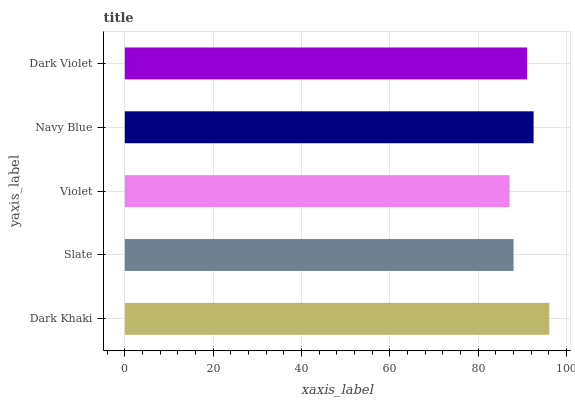Is Violet the minimum?
Answer yes or no. Yes. Is Dark Khaki the maximum?
Answer yes or no. Yes. Is Slate the minimum?
Answer yes or no. No. Is Slate the maximum?
Answer yes or no. No. Is Dark Khaki greater than Slate?
Answer yes or no. Yes. Is Slate less than Dark Khaki?
Answer yes or no. Yes. Is Slate greater than Dark Khaki?
Answer yes or no. No. Is Dark Khaki less than Slate?
Answer yes or no. No. Is Dark Violet the high median?
Answer yes or no. Yes. Is Dark Violet the low median?
Answer yes or no. Yes. Is Dark Khaki the high median?
Answer yes or no. No. Is Dark Khaki the low median?
Answer yes or no. No. 